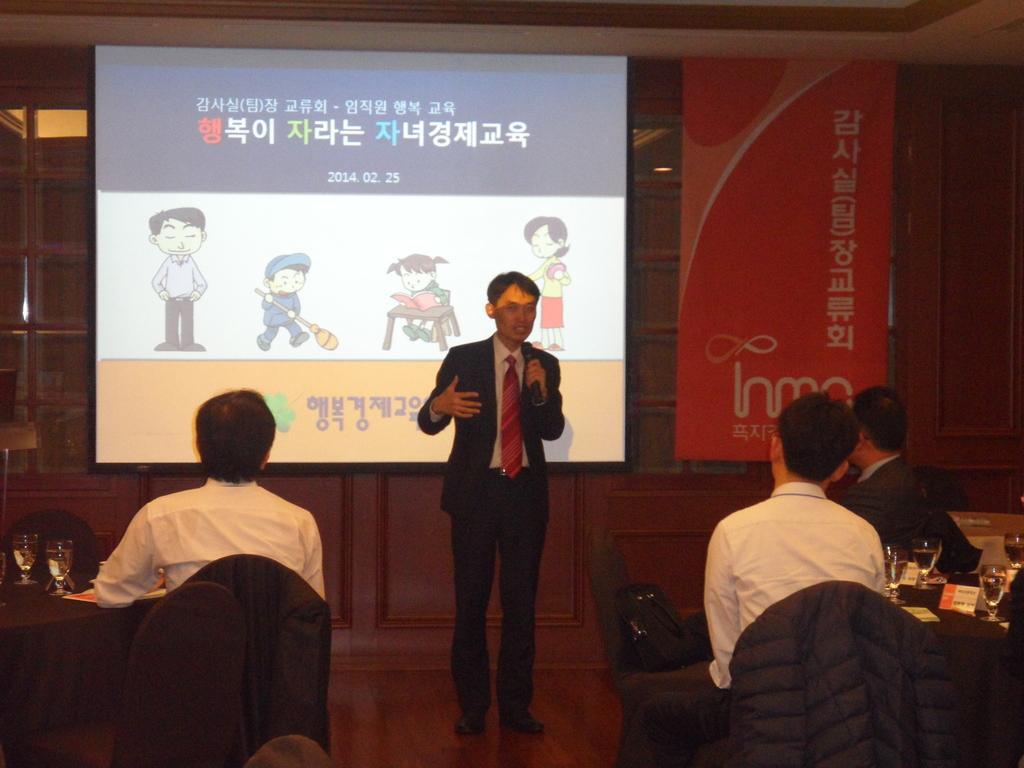Could you give a brief overview of what you see in this image? In the image we can see there is a man standing and he is holding mic in his hand. There are people sitting on the chair and on the table there are wine glasses. Behind there is a projector screen on the board. 